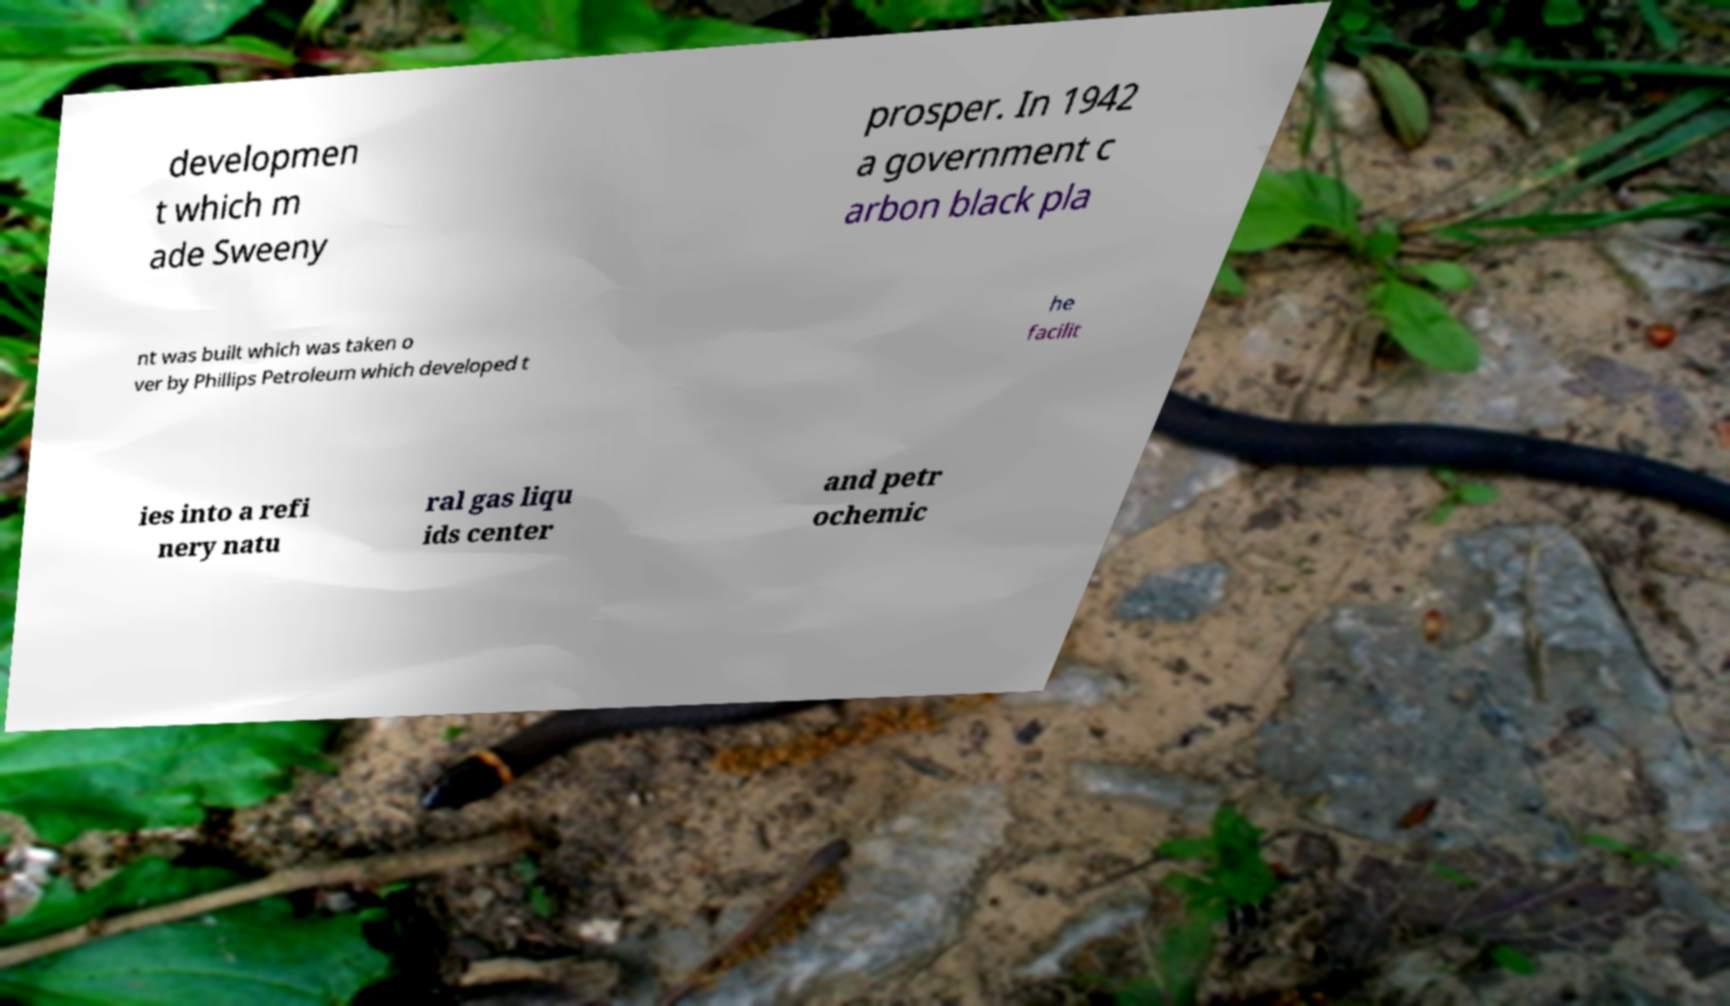For documentation purposes, I need the text within this image transcribed. Could you provide that? developmen t which m ade Sweeny prosper. In 1942 a government c arbon black pla nt was built which was taken o ver by Phillips Petroleum which developed t he facilit ies into a refi nery natu ral gas liqu ids center and petr ochemic 